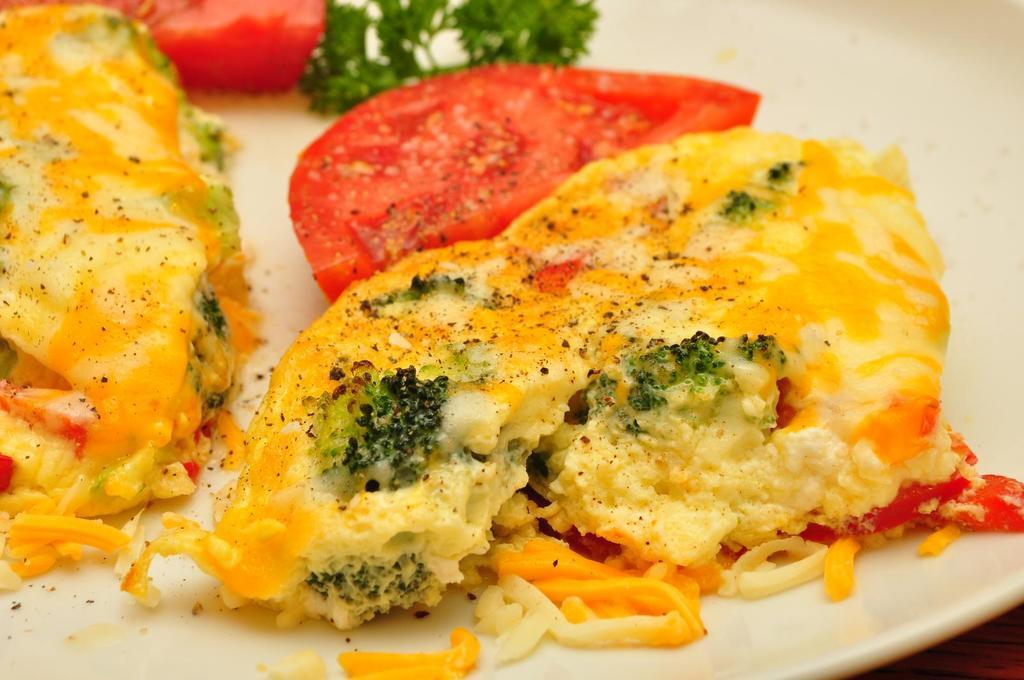What is present on the plate in the image? There is food in a plate in the image. Can you see a self in the image? There is no self present in the image. What type of fowl can be seen in the image? There is no fowl present in the image. 